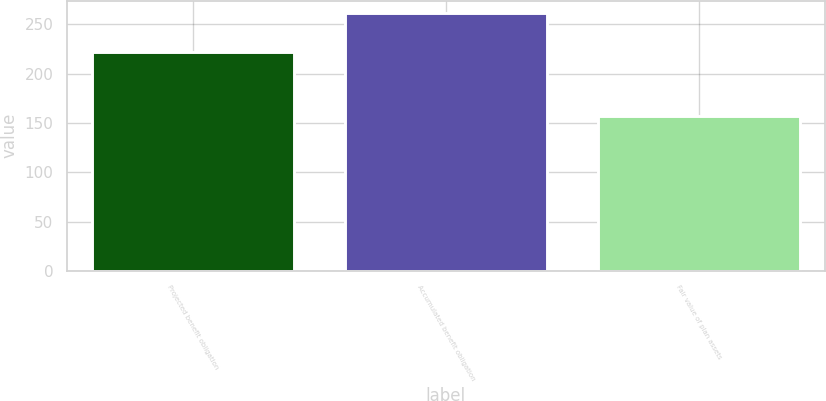Convert chart. <chart><loc_0><loc_0><loc_500><loc_500><bar_chart><fcel>Projected benefit obligation<fcel>Accumulated benefit obligation<fcel>Fair value of plan assets<nl><fcel>222.27<fcel>261.1<fcel>157.4<nl></chart> 